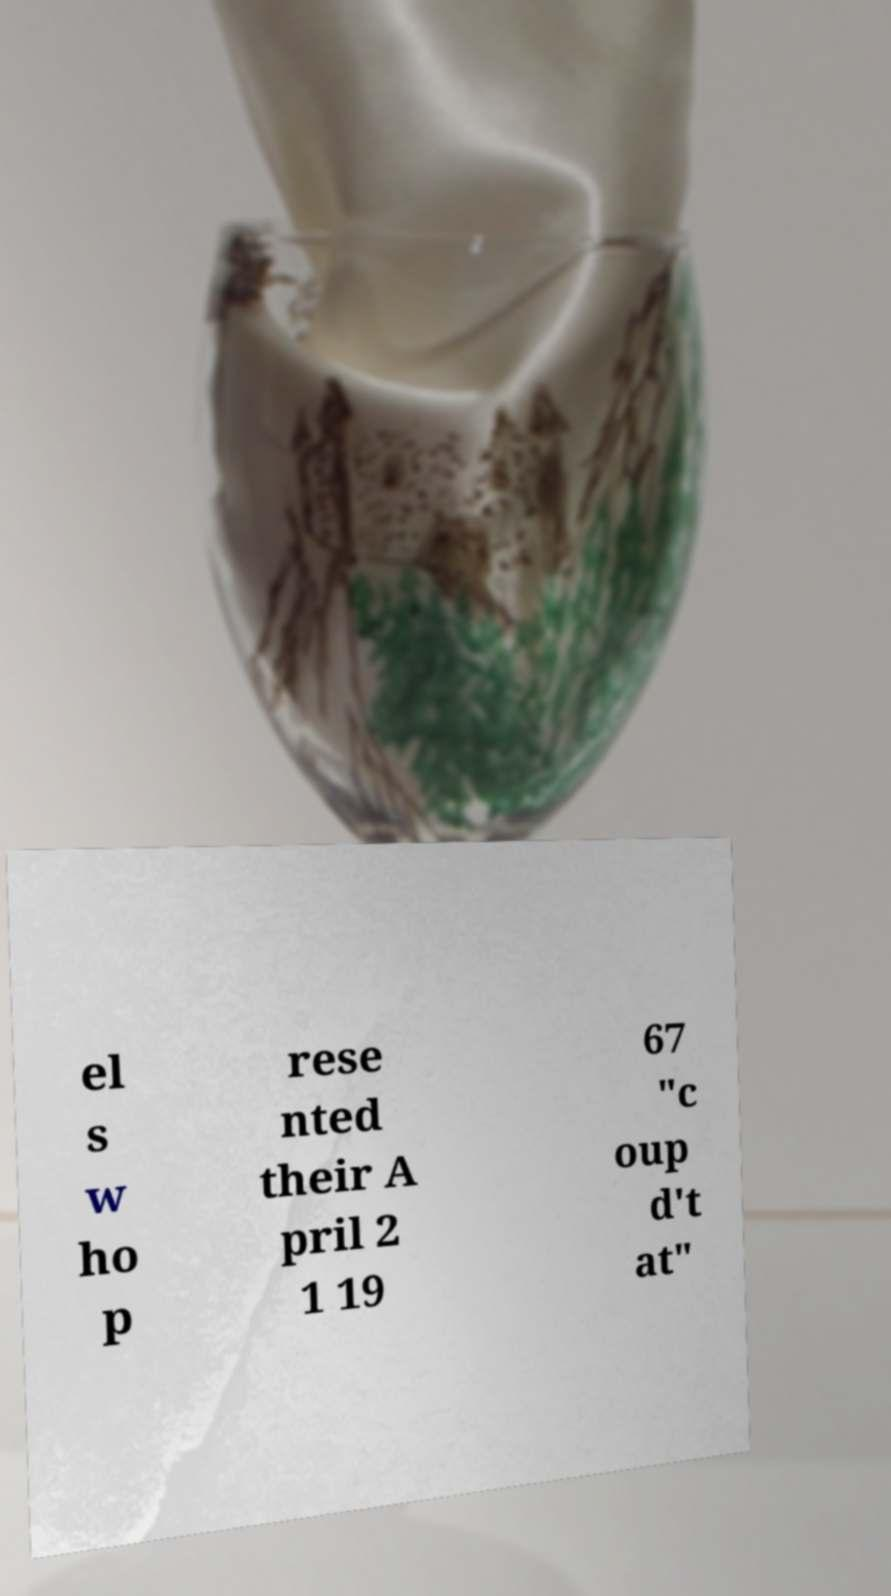There's text embedded in this image that I need extracted. Can you transcribe it verbatim? el s w ho p rese nted their A pril 2 1 19 67 "c oup d't at" 